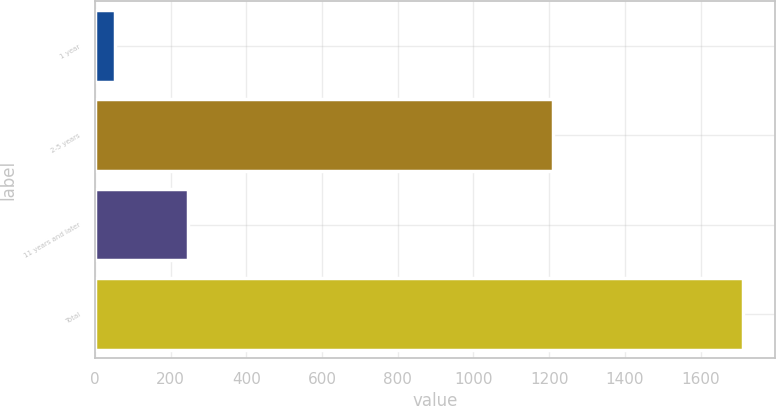Convert chart. <chart><loc_0><loc_0><loc_500><loc_500><bar_chart><fcel>1 year<fcel>2-5 years<fcel>11 years and later<fcel>Total<nl><fcel>52<fcel>1209<fcel>246<fcel>1712<nl></chart> 